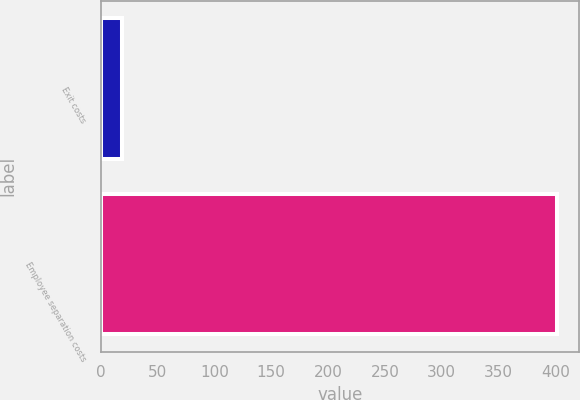Convert chart. <chart><loc_0><loc_0><loc_500><loc_500><bar_chart><fcel>Exit costs<fcel>Employee separation costs<nl><fcel>19<fcel>401<nl></chart> 